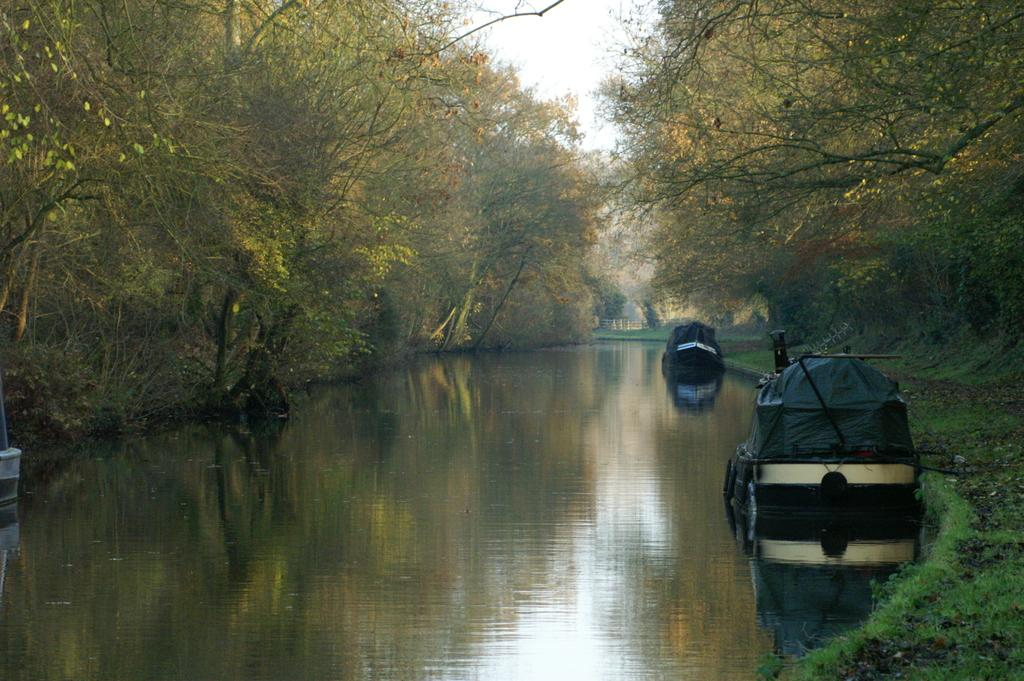What type of vegetation can be seen in the image? There are trees in the image. What is floating on the water in the image? There are boats floating on the water in the image. What is visible at the top of the image? The sky is visible at the top of the image. Where is the arch located in the image? There is no arch present in the image. What type of fruit can be seen growing on the trees in the image? There is no fruit visible on the trees in the image; only the trees themselves are present. 